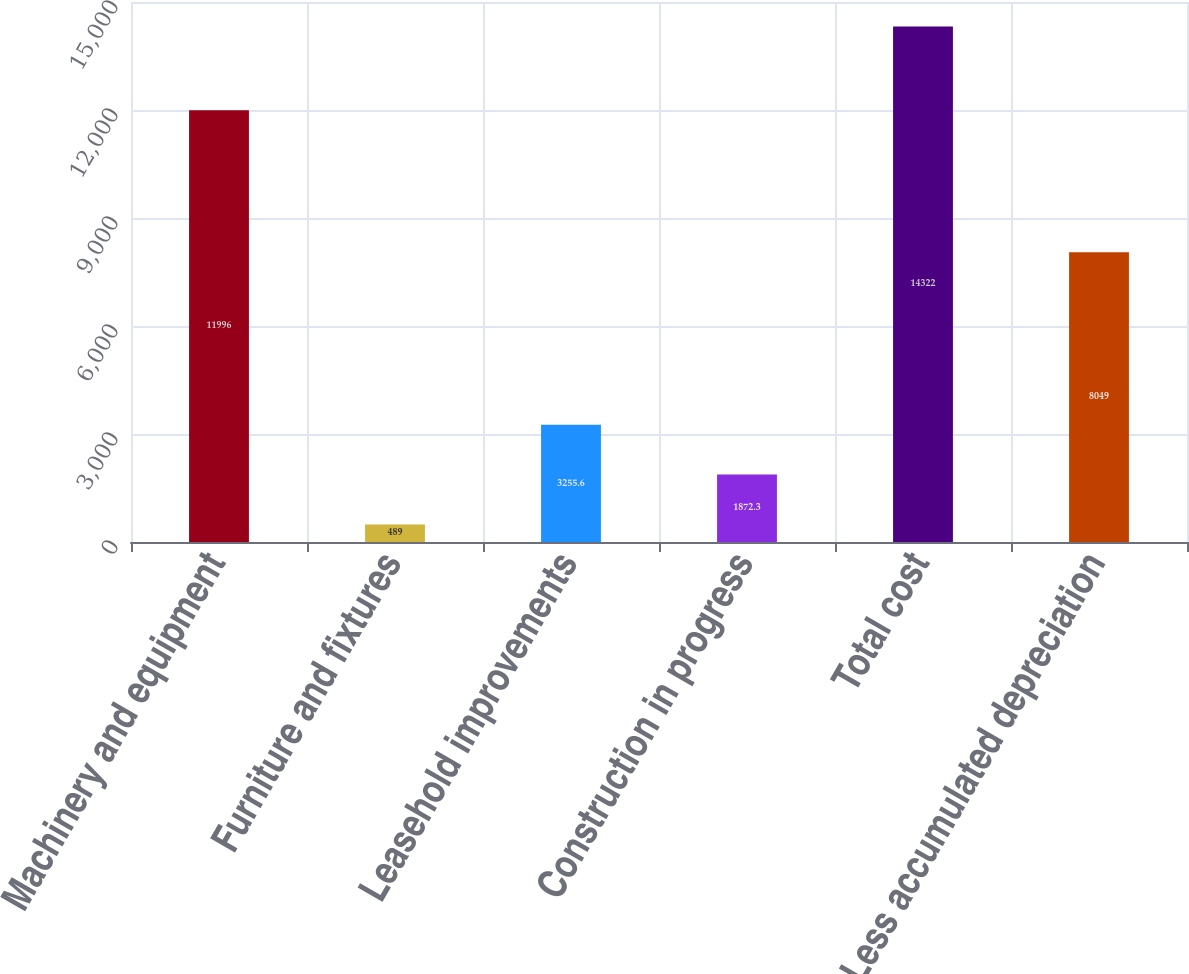Convert chart to OTSL. <chart><loc_0><loc_0><loc_500><loc_500><bar_chart><fcel>Machinery and equipment<fcel>Furniture and fixtures<fcel>Leasehold improvements<fcel>Construction in progress<fcel>Total cost<fcel>Less accumulated depreciation<nl><fcel>11996<fcel>489<fcel>3255.6<fcel>1872.3<fcel>14322<fcel>8049<nl></chart> 